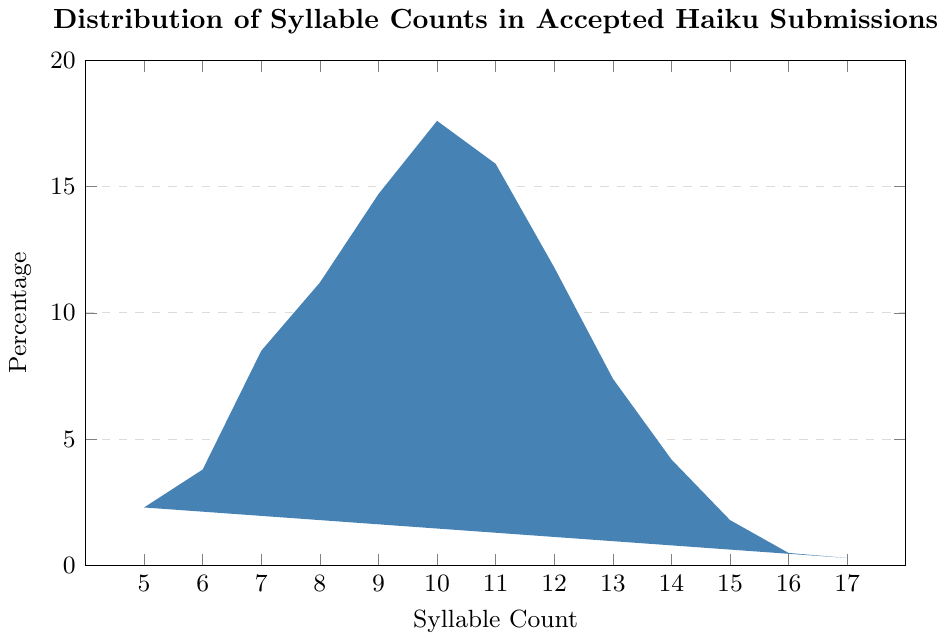What percentage of accepted haiku submissions have 10 syllables? Refer to the bar corresponding to 10 syllables on the 'Syllable Count' axis and check its height on the 'Percentage' axis.
Answer: 17.6% Which syllable count has the lowest percentage of accepted haiku submissions? The syllable count with the lowest bar height on the chart represents the lowest percentage. Identify the corresponding syllable count.
Answer: 17 By how much does the percentage of haiku with 9 syllables exceed that of haiku with 7 syllables? Find the percentages for both 9 and 7 syllables, then subtract the percentage of 7-syllable haiku from that of 9-syllable haiku.
Answer: 14.7% - 8.5% = 6.2% Between 8 and 11 syllables, which syllable count has the highest percentage of accepted haiku submissions? Compare the heights of the bars for syllable counts 8, 9, 10, and 11. Identify which has the greatest height.
Answer: 10 What is the total percentage of accepted haiku submissions with syllable counts ranging from 5 to 7? Sum the percentages of haiku with 5, 6, and 7 syllables: 2.3% + 3.8% + 8.5%
Answer: 14.6% What is the average percentage of accepted haiku submissions for syllable counts 12 to 14? Find the percentages of haiku with syllable counts 12, 13, and 14, and calculate the average: (11.8% + 7.4% + 4.2%) / 3
Answer: 7.8% How many syllable counts have a percentage higher than 10%? Count the number of bars with heights exceeding the 10% mark on the 'Percentage' axis.
Answer: 5 If you combine the percentages of haiku with 16 and 17 syllables, do they exceed 1%? Add the percentages for 16 and 17 syllables and compare the sum with 1%: 0.5% + 0.3%
Answer: No What is the difference in percentage between the syllable count with the highest and the lowest accepted haiku submissions? Identify the highest percentage (10 syllables) and the lowest percentage (17 syllables), then subtract the lowest percentage from the highest percentage: 17.6% - 0.3%
Answer: 17.3% How does the percentage of haiku with 11 syllables compare to those with 12 syllables? Compare the heights of the bars for 11 syllables and 12 syllables.
Answer: 11 > 12 